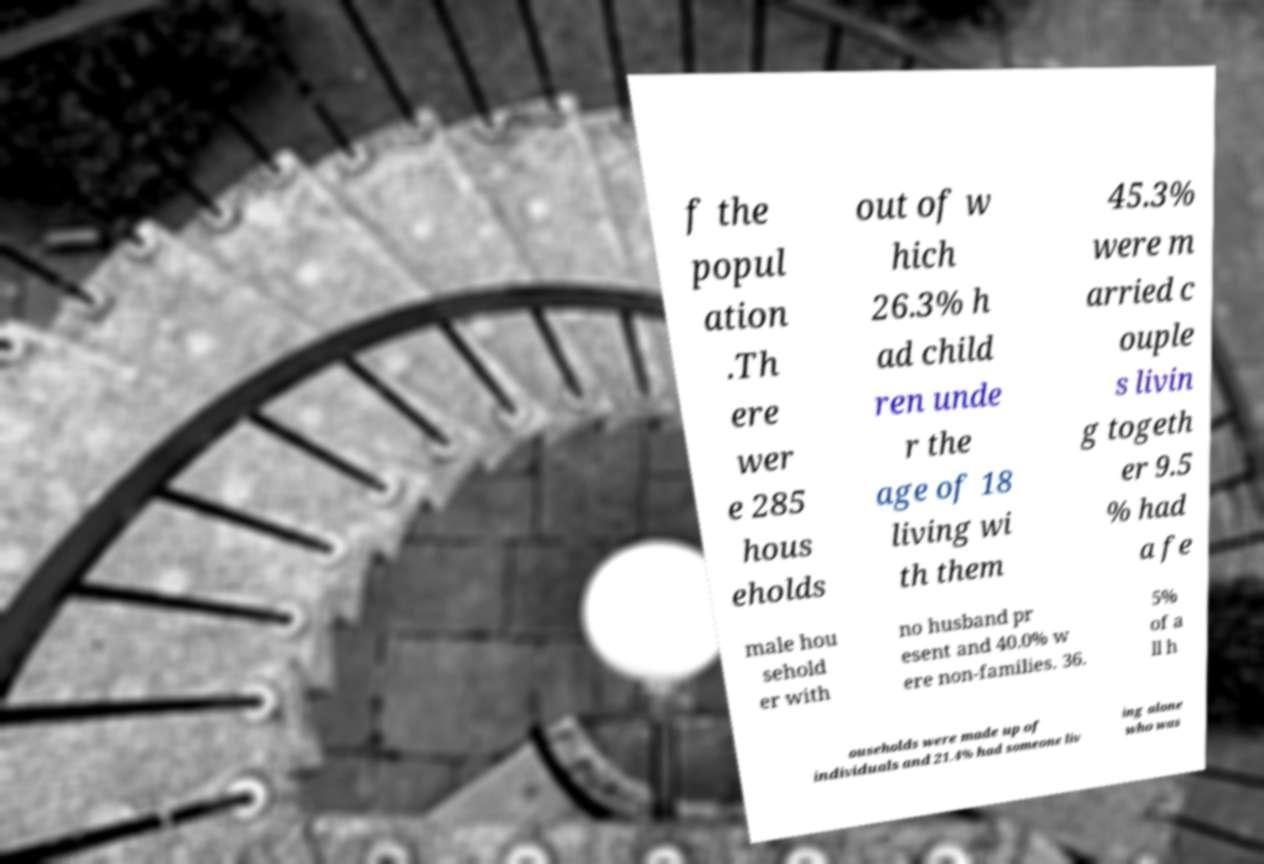Please identify and transcribe the text found in this image. f the popul ation .Th ere wer e 285 hous eholds out of w hich 26.3% h ad child ren unde r the age of 18 living wi th them 45.3% were m arried c ouple s livin g togeth er 9.5 % had a fe male hou sehold er with no husband pr esent and 40.0% w ere non-families. 36. 5% of a ll h ouseholds were made up of individuals and 21.4% had someone liv ing alone who was 